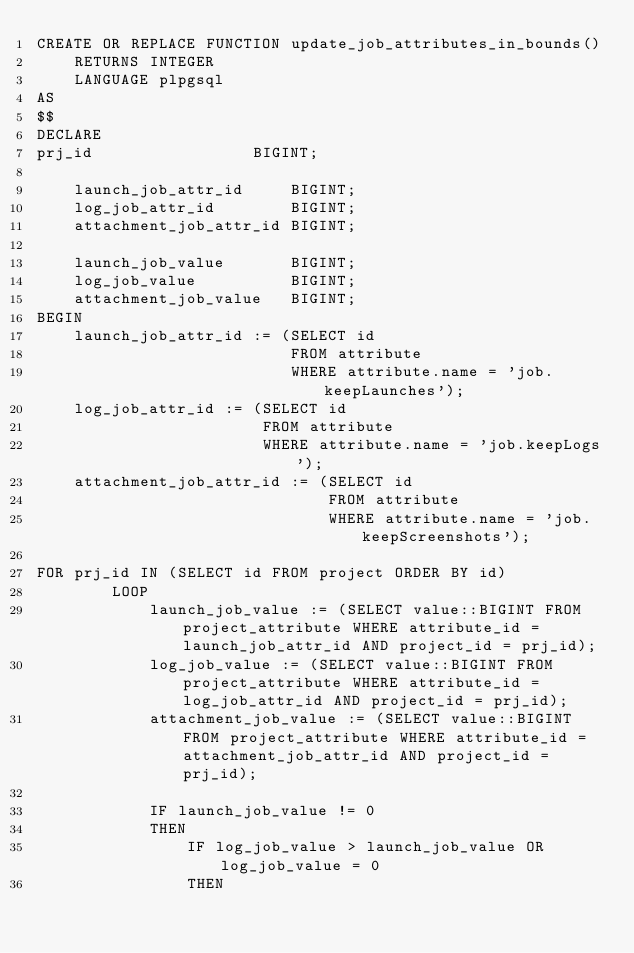<code> <loc_0><loc_0><loc_500><loc_500><_SQL_>CREATE OR REPLACE FUNCTION update_job_attributes_in_bounds()
    RETURNS INTEGER
    LANGUAGE plpgsql
AS
$$
DECLARE
prj_id                 BIGINT;

    launch_job_attr_id     BIGINT;
    log_job_attr_id        BIGINT;
    attachment_job_attr_id BIGINT;

    launch_job_value       BIGINT;
    log_job_value          BIGINT;
    attachment_job_value   BIGINT;
BEGIN
    launch_job_attr_id := (SELECT id
                           FROM attribute
                           WHERE attribute.name = 'job.keepLaunches');
    log_job_attr_id := (SELECT id
                        FROM attribute
                        WHERE attribute.name = 'job.keepLogs');
    attachment_job_attr_id := (SELECT id
                               FROM attribute
                               WHERE attribute.name = 'job.keepScreenshots');

FOR prj_id IN (SELECT id FROM project ORDER BY id)
        LOOP
            launch_job_value := (SELECT value::BIGINT FROM project_attribute WHERE attribute_id = launch_job_attr_id AND project_id = prj_id);
            log_job_value := (SELECT value::BIGINT FROM project_attribute WHERE attribute_id = log_job_attr_id AND project_id = prj_id);
            attachment_job_value := (SELECT value::BIGINT FROM project_attribute WHERE attribute_id = attachment_job_attr_id AND project_id = prj_id);

            IF launch_job_value != 0
            THEN
                IF log_job_value > launch_job_value OR log_job_value = 0
                THEN</code> 